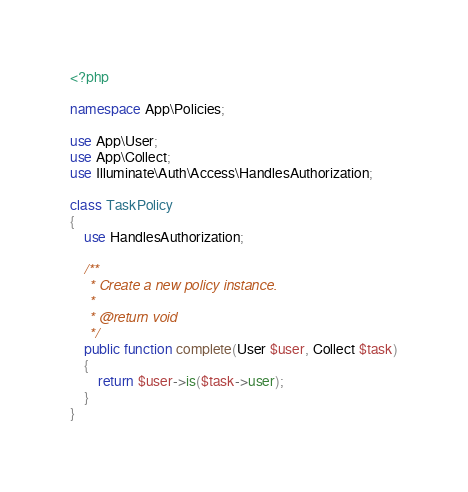Convert code to text. <code><loc_0><loc_0><loc_500><loc_500><_PHP_><?php

namespace App\Policies;

use App\User;
use App\Collect;
use Illuminate\Auth\Access\HandlesAuthorization;

class TaskPolicy
{
    use HandlesAuthorization;

    /**
     * Create a new policy instance.
     *
     * @return void
     */
    public function complete(User $user, Collect $task)
    {
        return $user->is($task->user);
    }
}
</code> 